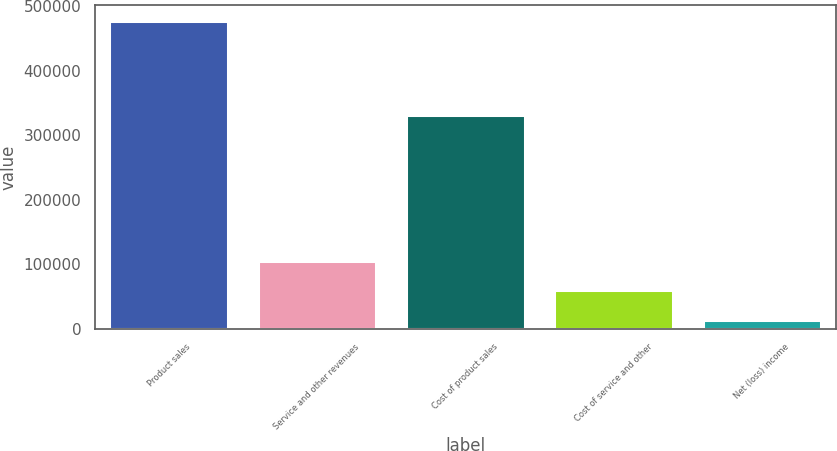Convert chart. <chart><loc_0><loc_0><loc_500><loc_500><bar_chart><fcel>Product sales<fcel>Service and other revenues<fcel>Cost of product sales<fcel>Cost of service and other<fcel>Net (loss) income<nl><fcel>477251<fcel>105901<fcel>331418<fcel>59481.8<fcel>13063<nl></chart> 